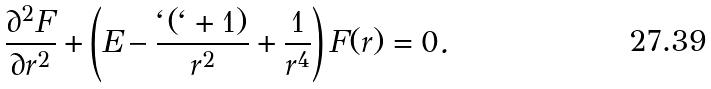Convert formula to latex. <formula><loc_0><loc_0><loc_500><loc_500>\frac { \partial ^ { 2 } F } { \partial r ^ { 2 } } + \left ( E - \frac { \ell ( \ell + 1 ) } { r ^ { 2 } } + \frac { 1 } { r ^ { 4 } } \right ) F ( r ) = 0 .</formula> 